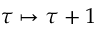<formula> <loc_0><loc_0><loc_500><loc_500>\tau \mapsto \tau + 1</formula> 